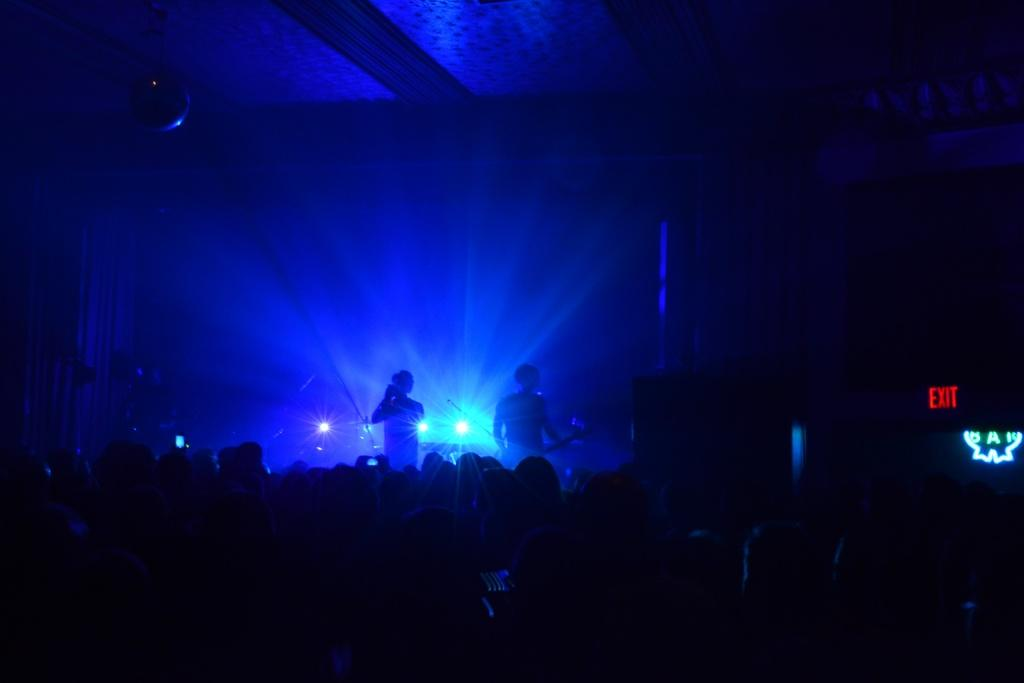What is the overall lighting condition of the image? The image is dark. What can be seen on the stage in the image? There are two persons standing on the stage. What else is visible in the image besides the stage and the persons? There are lights visible in the image. What part of the room can be seen above the stage? The ceiling is visible in the image. What type of goat is present on the stage in the image? There is no goat present on the stage or in the image. What valuable jewel is being displayed on the ceiling in the image? There is no jewel visible on the ceiling or in the image. 